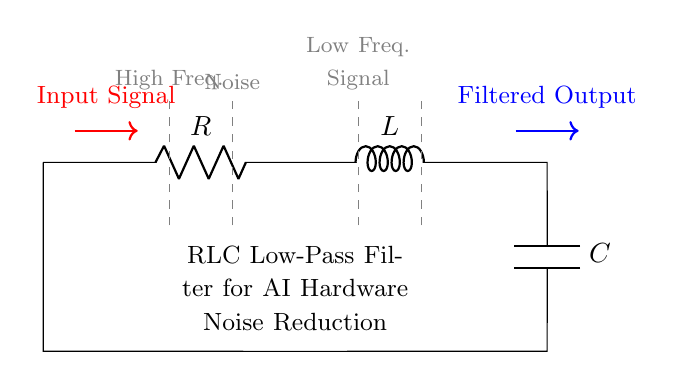What are the components in this circuit? The circuit comprises a resistor, an inductor, and a capacitor, which are labeled as R, L, and C respectively.
Answer: Resistor, Inductor, Capacitor What is the primary function of this circuit? The circuit functions as a low-pass filter, allowing low-frequency signals to pass while attenuating high-frequency noise.
Answer: Low-pass filter Which component is placed in series at the input? The resistor is the first component connected directly to the input signal, serving as the initial stage of the filter.
Answer: Resistor What type of circuit is represented here? The circuit is specifically a resistor-inductor-capacitor circuit, commonly used for filtering in electrical applications.
Answer: RLC circuit What frequency range does this filter primarily affect? The filter primarily affects high-frequency signals, as it is designed to attenuate these while allowing lower frequencies to pass.
Answer: High Frequency How does the function of the inductor differ from that of the capacitor in this circuit? The inductor stores energy in its magnetic field and helps to block high-frequency signals, while the capacitor stores energy in its electric field and allows low-frequency signals to pass through.
Answer: Opposing high frequency, allowing low frequency What is indicated by the dashed lines within the circuit diagram? The dashed lines highlight the frequency ranges where the circuits operate, indicating where high frequencies are attenuated and low frequencies are preserved.
Answer: Frequency ranges 